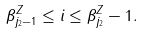Convert formula to latex. <formula><loc_0><loc_0><loc_500><loc_500>\beta _ { j _ { 2 } - 1 } ^ { Z } \leq i \leq \beta _ { j _ { 2 } } ^ { Z } - 1 .</formula> 